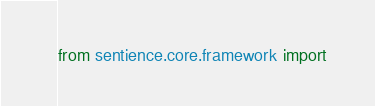<code> <loc_0><loc_0><loc_500><loc_500><_Python_>from sentience.core.framework import </code> 